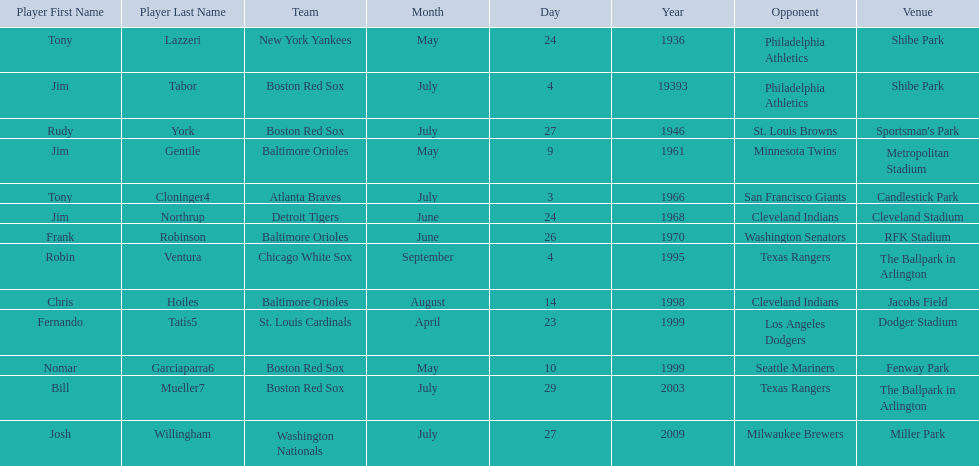What venue did detroit play cleveland in? Cleveland Stadium. Who was the player? Jim Northrup. What date did they play? June 24, 1968. 